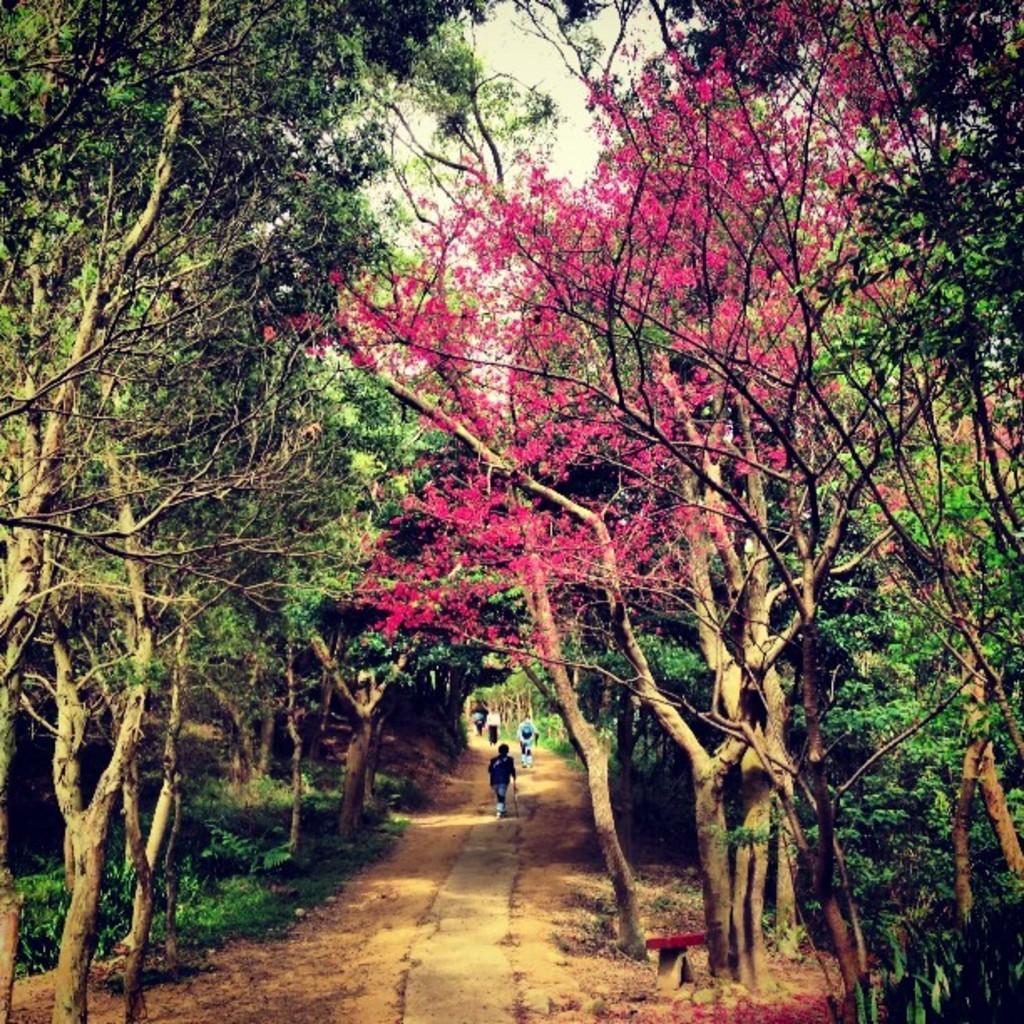Can you describe this image briefly? In this picture there are group of people walking. There are trees and there are pink color flowers on the tree. At the top there is sky. At the bottom there is grass. 